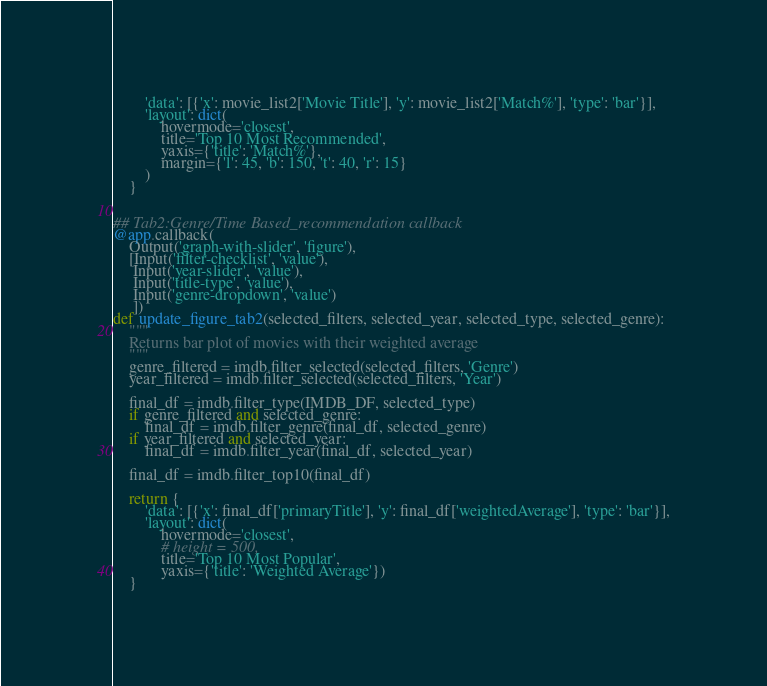<code> <loc_0><loc_0><loc_500><loc_500><_Python_>        'data': [{'x': movie_list2['Movie Title'], 'y': movie_list2['Match%'], 'type': 'bar'}],
        'layout': dict(
            hovermode='closest',
            title='Top 10 Most Recommended',
            yaxis={'title': 'Match%'},
            margin={'l': 45, 'b': 150, 't': 40, 'r': 15}
        )
    }


## Tab2:Genre/Time Based_recommendation callback
@app.callback(
    Output('graph-with-slider', 'figure'),
    [Input('filter-checklist', 'value'),
     Input('year-slider', 'value'),
     Input('title-type', 'value'),
     Input('genre-dropdown', 'value')
     ])
def update_figure_tab2(selected_filters, selected_year, selected_type, selected_genre):
    """
    Returns bar plot of movies with their weighted average
    """
    genre_filtered = imdb.filter_selected(selected_filters, 'Genre')
    year_filtered = imdb.filter_selected(selected_filters, 'Year')

    final_df = imdb.filter_type(IMDB_DF, selected_type)
    if genre_filtered and selected_genre:
        final_df = imdb.filter_genre(final_df, selected_genre)
    if year_filtered and selected_year:
        final_df = imdb.filter_year(final_df, selected_year)

    final_df = imdb.filter_top10(final_df)

    return {
        'data': [{'x': final_df['primaryTitle'], 'y': final_df['weightedAverage'], 'type': 'bar'}],
        'layout': dict(
            hovermode='closest',
            # height = 500,
            title='Top 10 Most Popular',
            yaxis={'title': 'Weighted Average'})
    }
</code> 